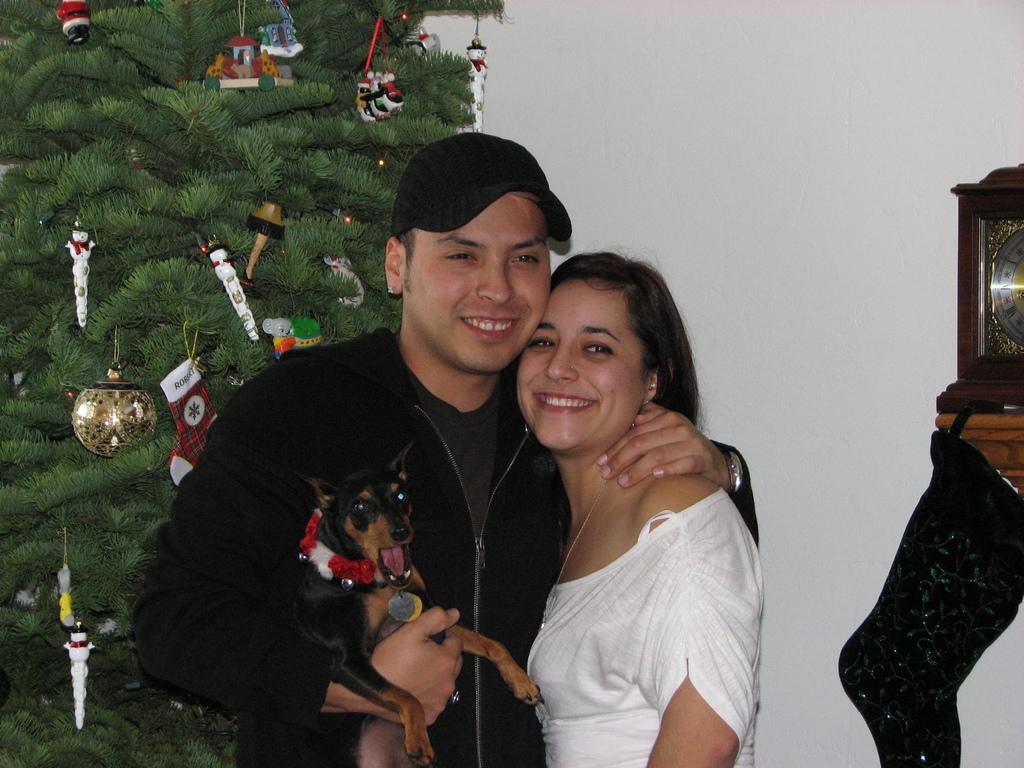How would you summarize this image in a sentence or two? I can see in this image a women and men are standing and smiling together. I can also see there is a Christmas tree behind these people. 